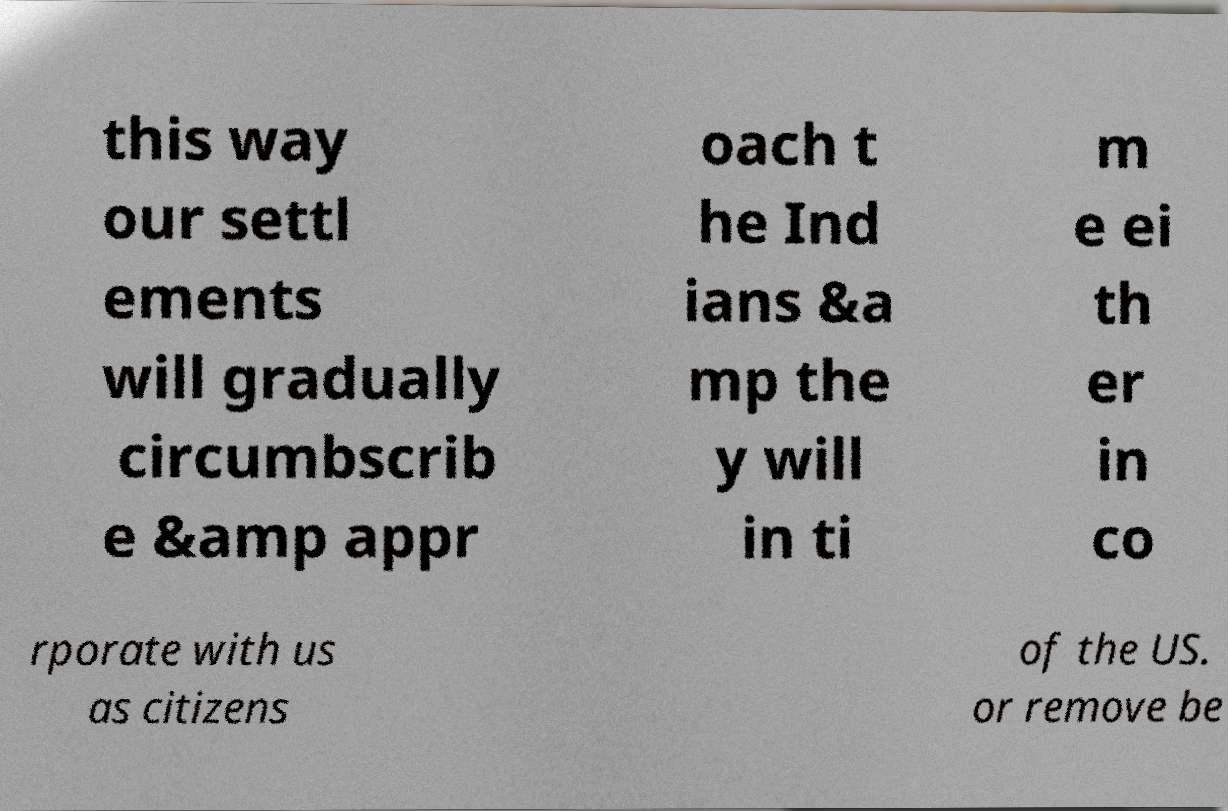Please identify and transcribe the text found in this image. this way our settl ements will gradually circumbscrib e &amp appr oach t he Ind ians &a mp the y will in ti m e ei th er in co rporate with us as citizens of the US. or remove be 